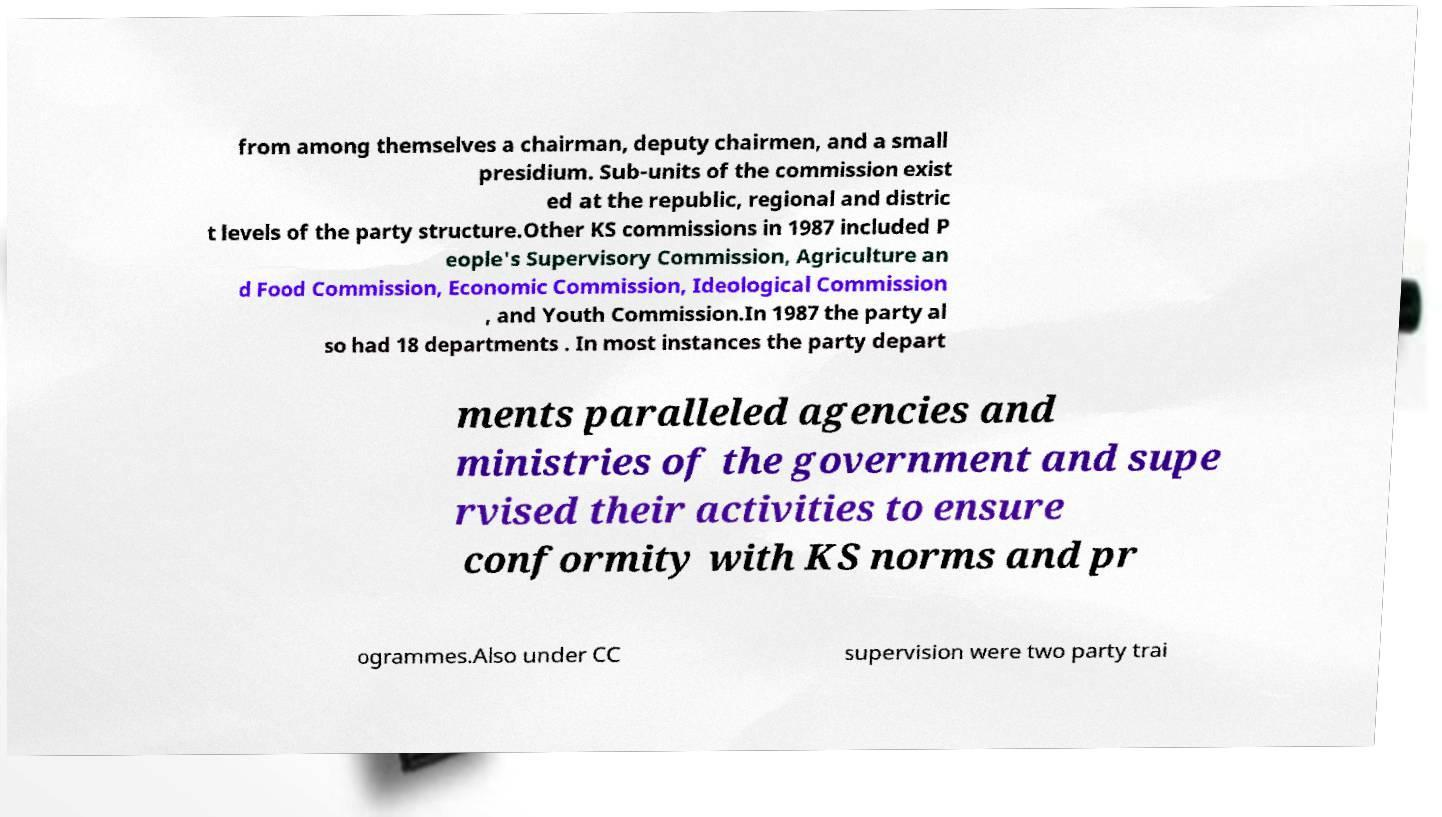Please identify and transcribe the text found in this image. from among themselves a chairman, deputy chairmen, and a small presidium. Sub-units of the commission exist ed at the republic, regional and distric t levels of the party structure.Other KS commissions in 1987 included P eople's Supervisory Commission, Agriculture an d Food Commission, Economic Commission, Ideological Commission , and Youth Commission.In 1987 the party al so had 18 departments . In most instances the party depart ments paralleled agencies and ministries of the government and supe rvised their activities to ensure conformity with KS norms and pr ogrammes.Also under CC supervision were two party trai 